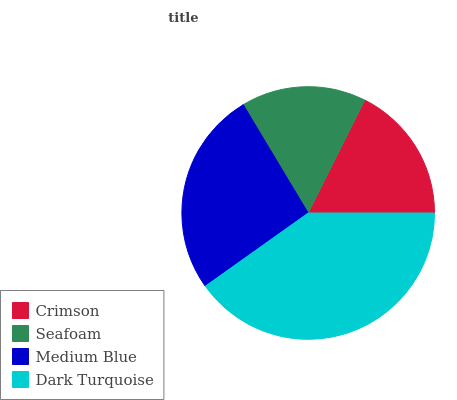Is Seafoam the minimum?
Answer yes or no. Yes. Is Dark Turquoise the maximum?
Answer yes or no. Yes. Is Medium Blue the minimum?
Answer yes or no. No. Is Medium Blue the maximum?
Answer yes or no. No. Is Medium Blue greater than Seafoam?
Answer yes or no. Yes. Is Seafoam less than Medium Blue?
Answer yes or no. Yes. Is Seafoam greater than Medium Blue?
Answer yes or no. No. Is Medium Blue less than Seafoam?
Answer yes or no. No. Is Medium Blue the high median?
Answer yes or no. Yes. Is Crimson the low median?
Answer yes or no. Yes. Is Seafoam the high median?
Answer yes or no. No. Is Seafoam the low median?
Answer yes or no. No. 